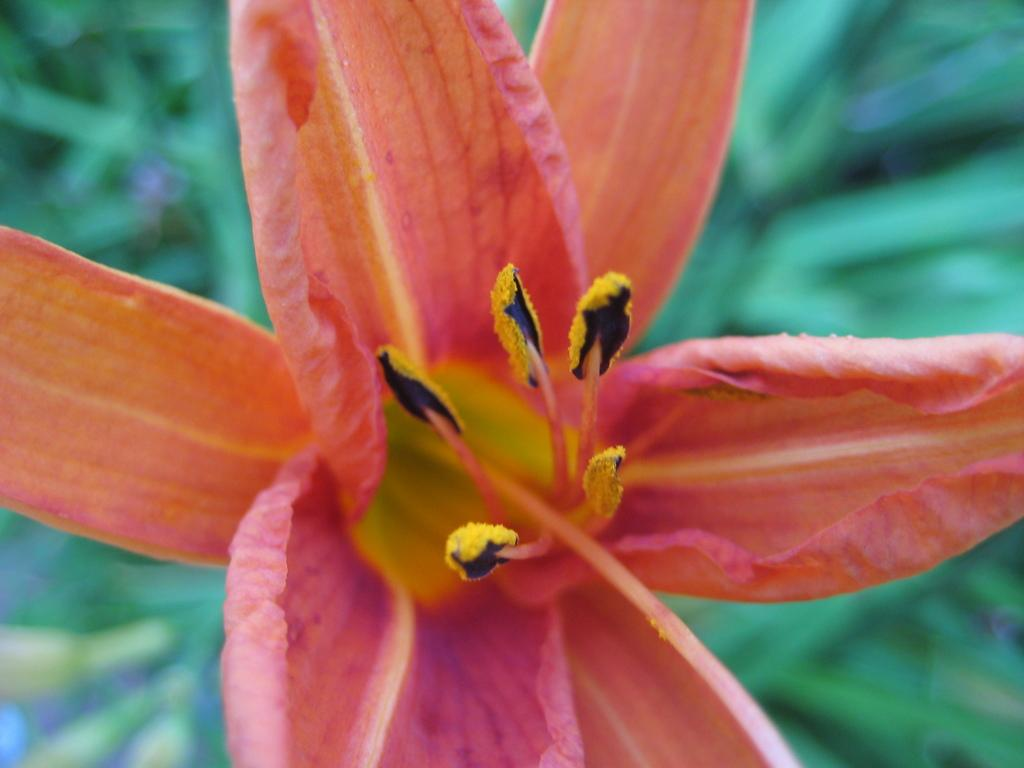What is the main subject of the image? There is a flower in the image. Can you describe the background of the image? The background of the image is blue and green. What type of class is being held in the image? There is no class present in the image; it features a flower and a blue and green background. What kind of apparel is the flower wearing in the image? The flower is a plant and does not wear apparel. 